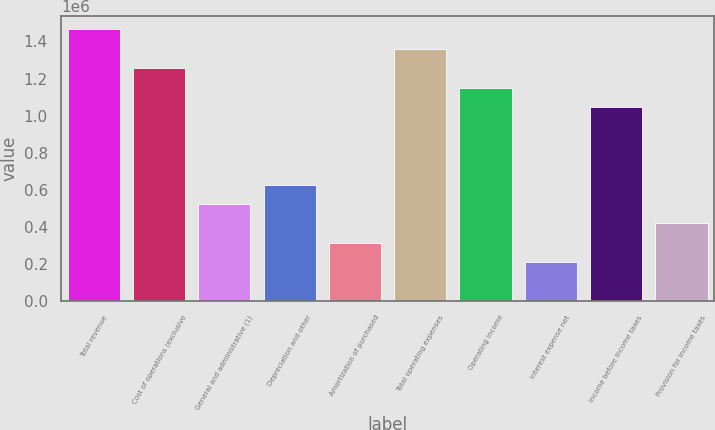Convert chart to OTSL. <chart><loc_0><loc_0><loc_500><loc_500><bar_chart><fcel>Total revenue<fcel>Cost of operations (exclusive<fcel>General and administrative (1)<fcel>Depreciation and other<fcel>Amortization of purchased<fcel>Total operating expenses<fcel>Operating income<fcel>Interest expense net<fcel>Income before income taxes<fcel>Provision for income taxes<nl><fcel>1.46516e+06<fcel>1.25585e+06<fcel>523272<fcel>627927<fcel>313964<fcel>1.36051e+06<fcel>1.1512e+06<fcel>209309<fcel>1.04654e+06<fcel>418618<nl></chart> 